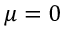Convert formula to latex. <formula><loc_0><loc_0><loc_500><loc_500>\mu = 0</formula> 